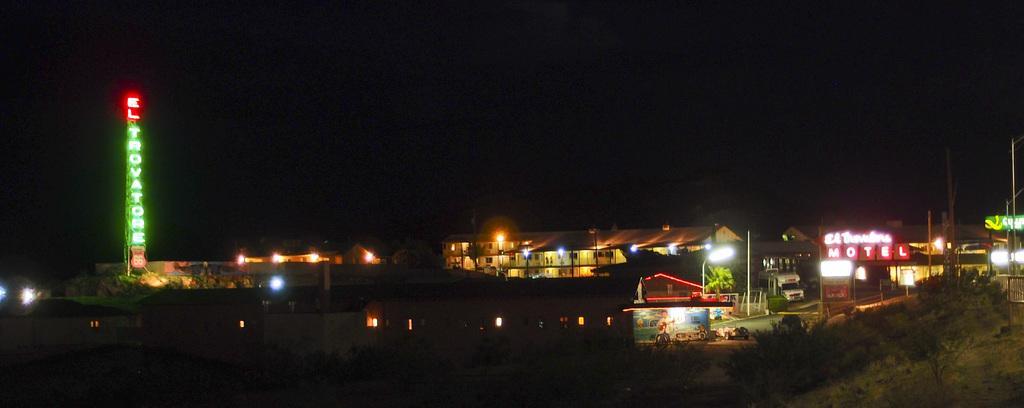Can you describe this image briefly? In this image we can see buildings, shops, plants and one tower. To the right side of the image one fence is present. 